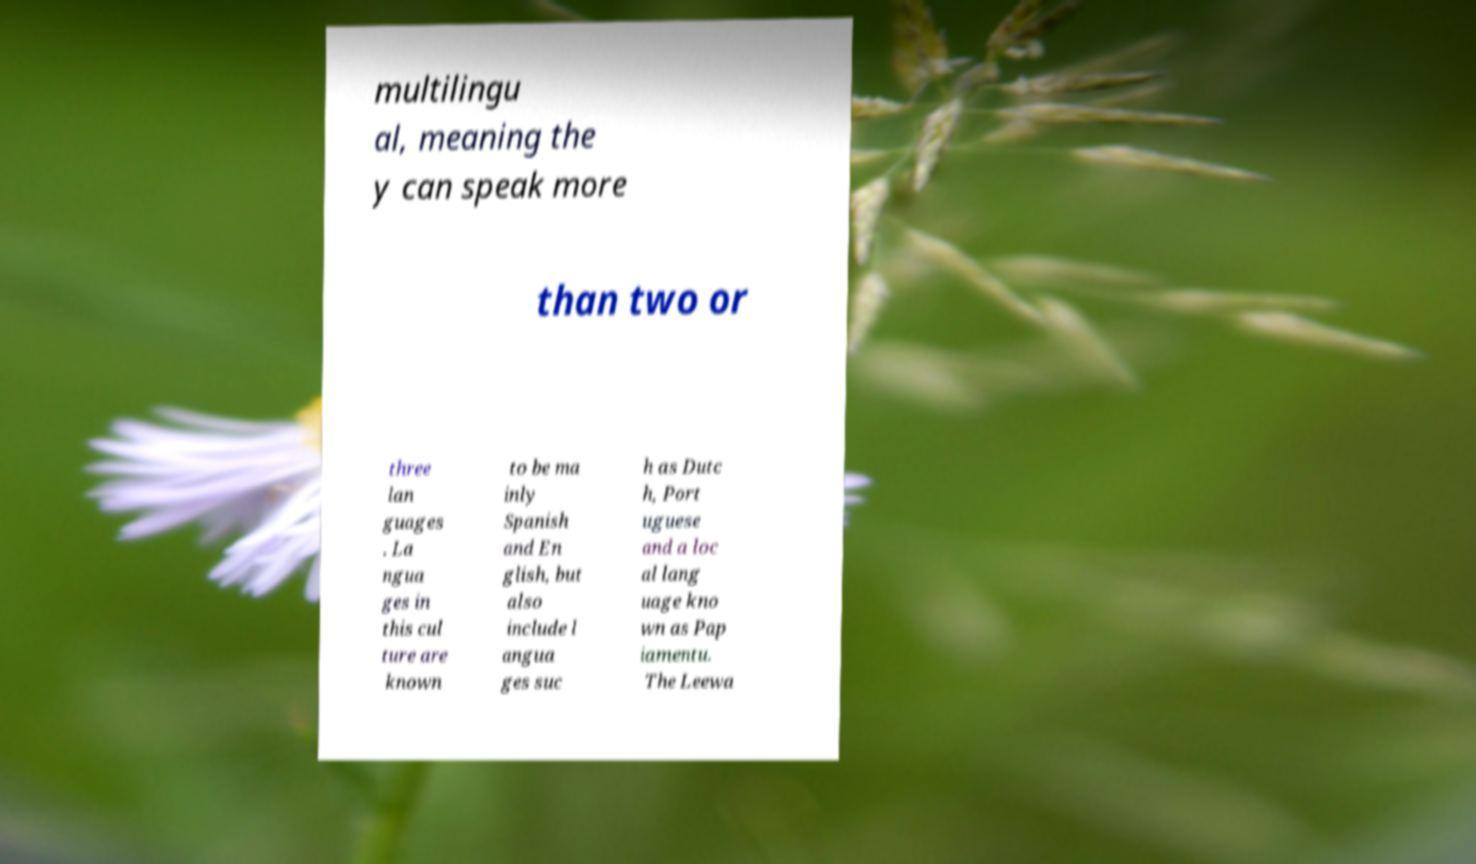Can you read and provide the text displayed in the image?This photo seems to have some interesting text. Can you extract and type it out for me? multilingu al, meaning the y can speak more than two or three lan guages . La ngua ges in this cul ture are known to be ma inly Spanish and En glish, but also include l angua ges suc h as Dutc h, Port uguese and a loc al lang uage kno wn as Pap iamentu. The Leewa 